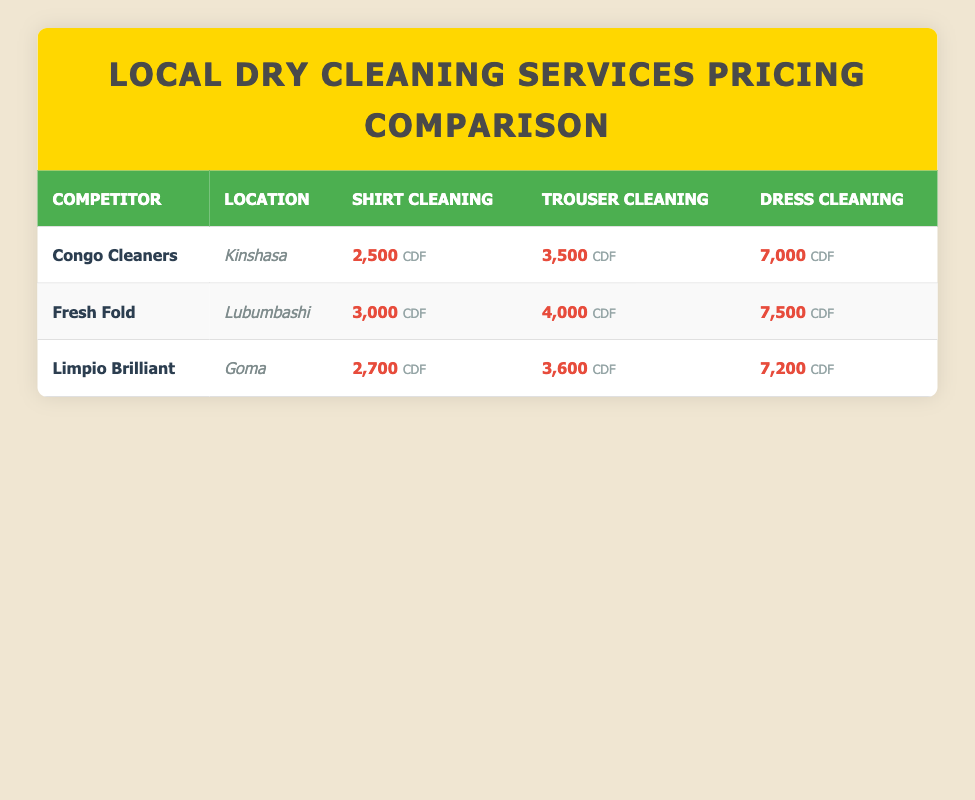What is the price of shirt cleaning at Congo Cleaners? The table states that the price listed for shirt cleaning at Congo Cleaners is 2,500 CDF.
Answer: 2,500 CDF Which competitor has the highest price for trouser cleaning? By comparing the prices for trouser cleaning from all competitors, Fresh Fold has the highest price at 4,000 CDF.
Answer: Fresh Fold at 4,000 CDF What is the average price for dress cleaning across all competitors? To get the average price, we will add the prices for dress cleaning from all competitors: (7,000 + 7,500 + 7,200) = 21,700 CDF. Dividing this sum by the number of competitors (3), we find that the average price is 21,700 / 3 = 7,233.33 CDF.
Answer: 7,233.33 CDF Does Limpio Brilliant offer cheaper shirt cleaning than Congo Cleaners? According to the table, Limpio Brilliant charges 2,700 CDF for shirt cleaning, which is more expensive than the 2,500 CDF charged by Congo Cleaners. Therefore, the statement is false.
Answer: No What is the total cost for a customer who wants to clean one shirt, one trouser, and one dress at Congo Cleaners? The total cost can be calculated by adding the prices for each service at Congo Cleaners: 2,500 CDF (shirt) + 3,500 CDF (trouser) + 7,000 CDF (dress) = 13,000 CDF.
Answer: 13,000 CDF Which competitor offers shirt cleaning for less than 3,000 CDF? From the table, both Congo Cleaners (2,500 CDF) and Limpio Brilliant (2,700 CDF) offer shirt cleaning for less than 3,000 CDF, making the statement true for these two competitors.
Answer: Congo Cleaners and Limpio Brilliant What is the price difference of dress cleaning between Fresh Fold and Limpio Brilliant? To find the price difference, subtract the price at Limpio Brilliant (7,200 CDF) from the price at Fresh Fold (7,500 CDF): 7,500 CDF - 7,200 CDF = 300 CDF.
Answer: 300 CDF Which location has the lowest price for trouser cleaning? By examining the trouser cleaning prices, Congo Cleaners has the lowest price at 3,500 CDF compared to the others which are higher.
Answer: Congo Cleaners at 3,500 CDF 